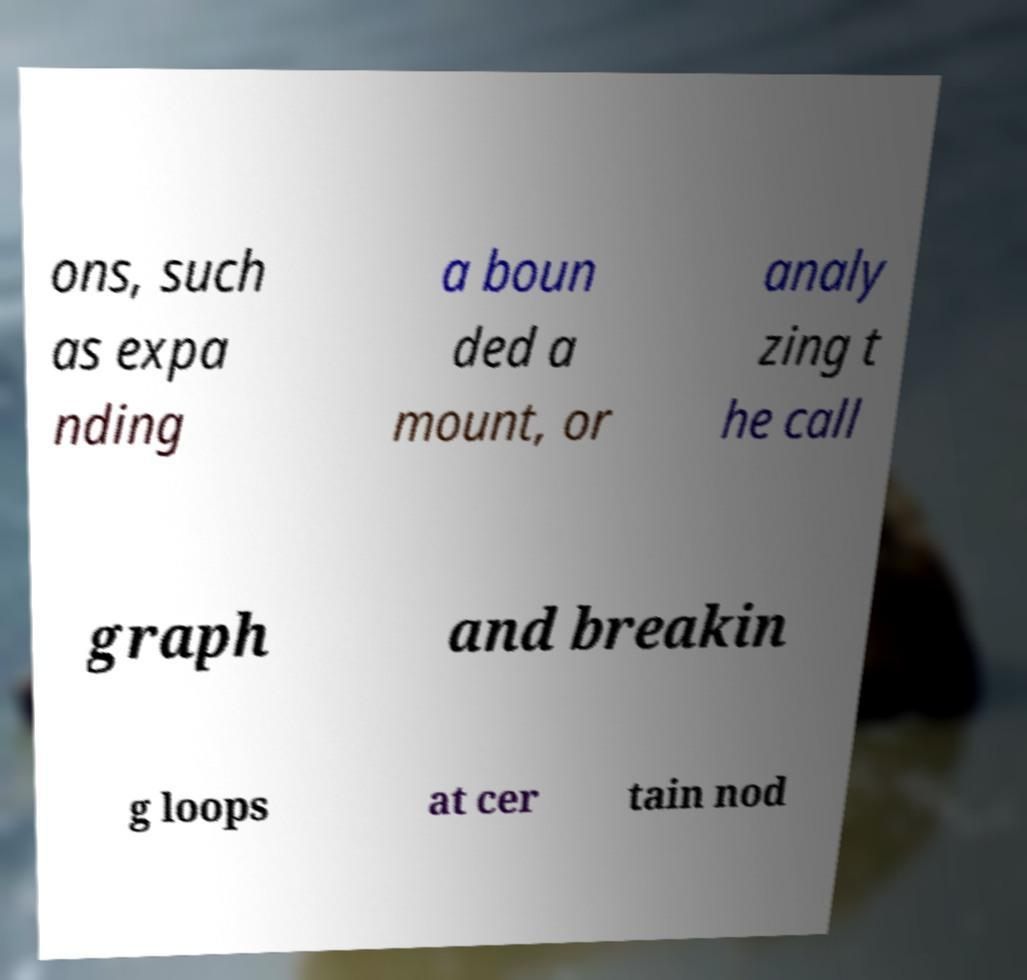Please read and relay the text visible in this image. What does it say? ons, such as expa nding a boun ded a mount, or analy zing t he call graph and breakin g loops at cer tain nod 